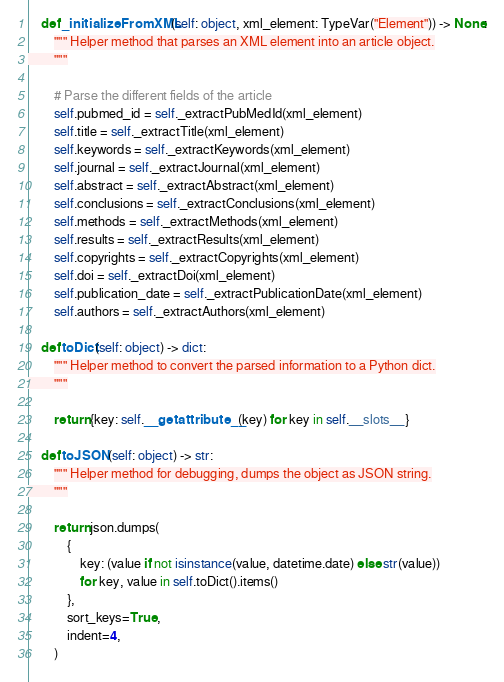Convert code to text. <code><loc_0><loc_0><loc_500><loc_500><_Python_>    def _initializeFromXML(self: object, xml_element: TypeVar("Element")) -> None:
        """ Helper method that parses an XML element into an article object.
        """

        # Parse the different fields of the article
        self.pubmed_id = self._extractPubMedId(xml_element)
        self.title = self._extractTitle(xml_element)
        self.keywords = self._extractKeywords(xml_element)
        self.journal = self._extractJournal(xml_element)
        self.abstract = self._extractAbstract(xml_element)
        self.conclusions = self._extractConclusions(xml_element)
        self.methods = self._extractMethods(xml_element)
        self.results = self._extractResults(xml_element)
        self.copyrights = self._extractCopyrights(xml_element)
        self.doi = self._extractDoi(xml_element)
        self.publication_date = self._extractPublicationDate(xml_element)
        self.authors = self._extractAuthors(xml_element)

    def toDict(self: object) -> dict:
        """ Helper method to convert the parsed information to a Python dict.
        """

        return {key: self.__getattribute__(key) for key in self.__slots__}

    def toJSON(self: object) -> str:
        """ Helper method for debugging, dumps the object as JSON string.
        """

        return json.dumps(
            {
                key: (value if not isinstance(value, datetime.date) else str(value))
                for key, value in self.toDict().items()
            },
            sort_keys=True,
            indent=4,
        )
</code> 